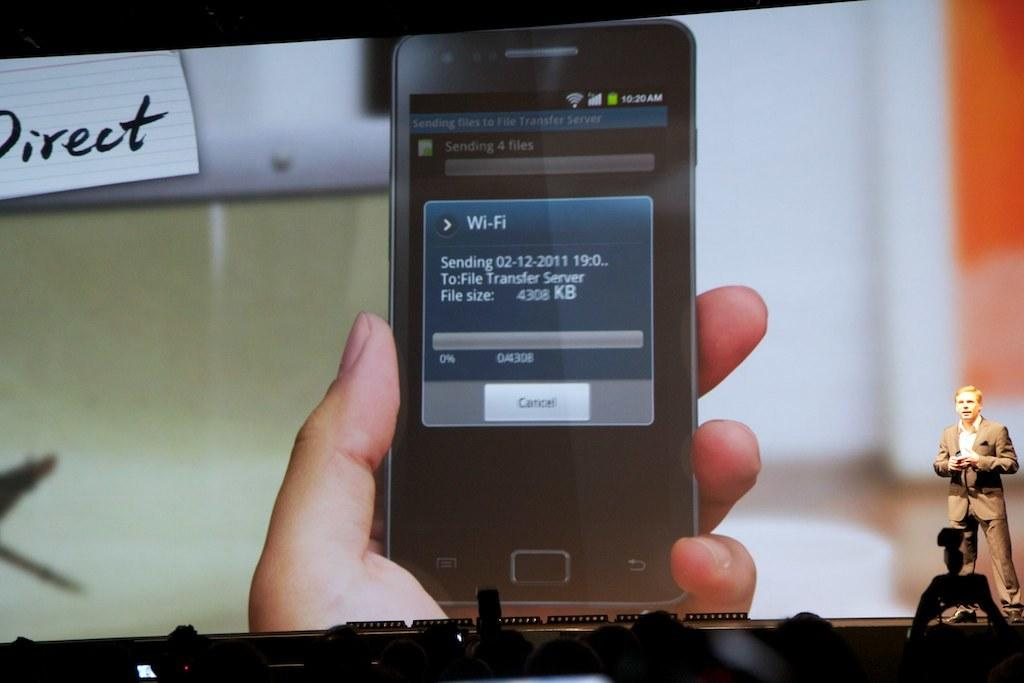<image>
Create a compact narrative representing the image presented. A smartphone that is being held in someone's hand shows that a file transfer is taking place. 